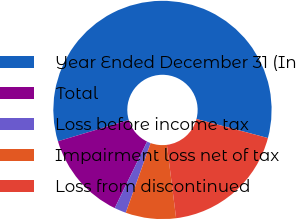<chart> <loc_0><loc_0><loc_500><loc_500><pie_chart><fcel>Year Ended December 31 (In<fcel>Total<fcel>Loss before income tax<fcel>Impairment loss net of tax<fcel>Loss from discontinued<nl><fcel>58.78%<fcel>13.16%<fcel>1.75%<fcel>7.45%<fcel>18.86%<nl></chart> 